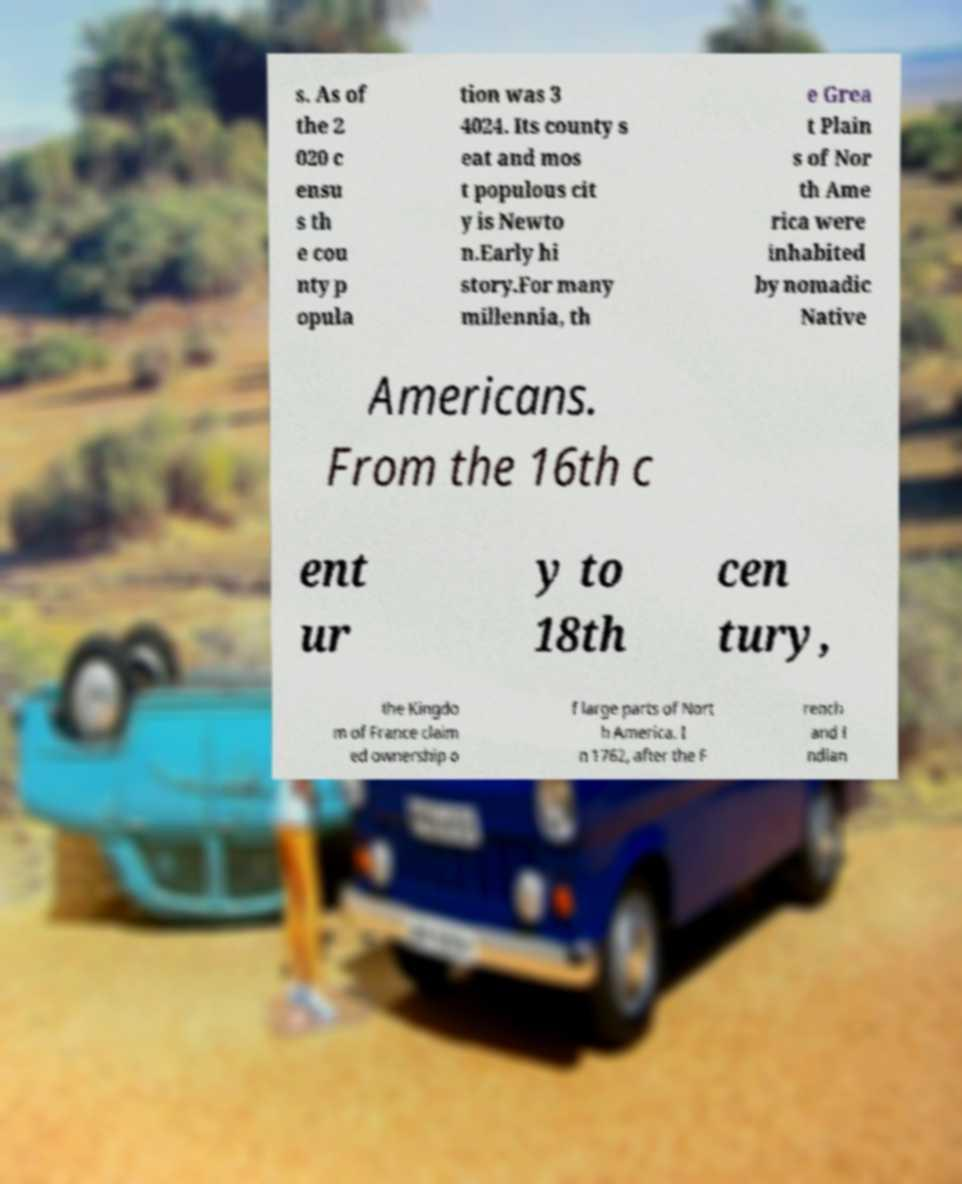Please read and relay the text visible in this image. What does it say? s. As of the 2 020 c ensu s th e cou nty p opula tion was 3 4024. Its county s eat and mos t populous cit y is Newto n.Early hi story.For many millennia, th e Grea t Plain s of Nor th Ame rica were inhabited by nomadic Native Americans. From the 16th c ent ur y to 18th cen tury, the Kingdo m of France claim ed ownership o f large parts of Nort h America. I n 1762, after the F rench and I ndian 